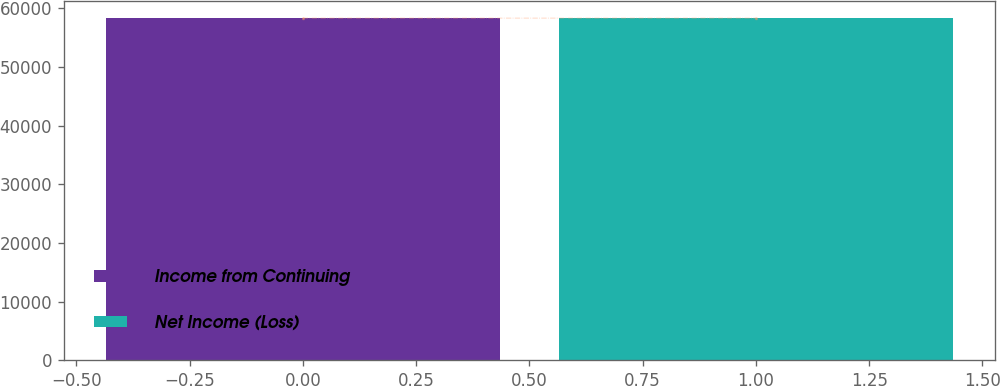Convert chart to OTSL. <chart><loc_0><loc_0><loc_500><loc_500><bar_chart><fcel>Income from Continuing<fcel>Net Income (Loss)<nl><fcel>58292.1<fcel>58292.2<nl></chart> 